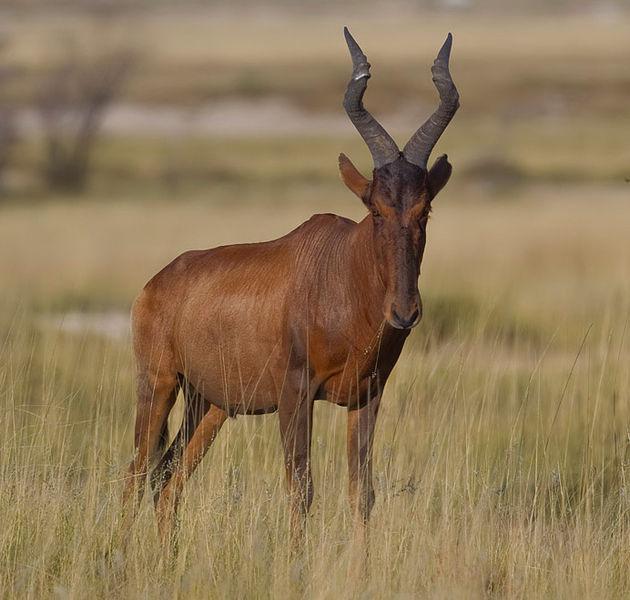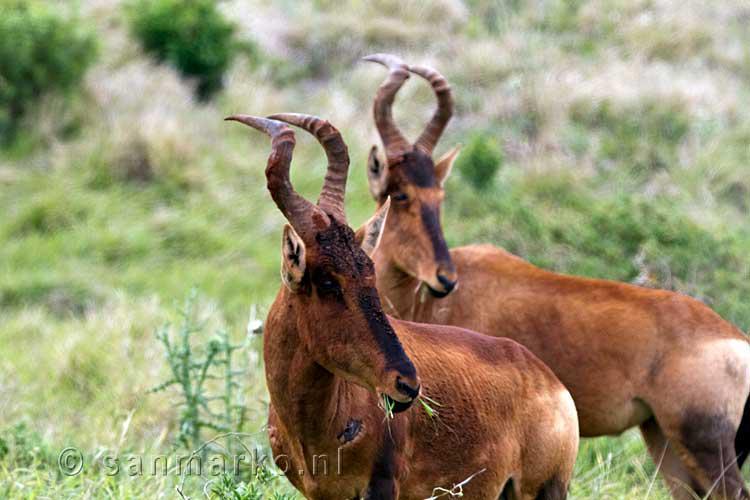The first image is the image on the left, the second image is the image on the right. Examine the images to the left and right. Is the description "An image shows exactly two horned animals, which are facing each other." accurate? Answer yes or no. No. The first image is the image on the left, the second image is the image on the right. Assess this claim about the two images: "There is an animal looks straight at the camera". Correct or not? Answer yes or no. Yes. 